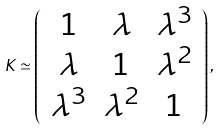<formula> <loc_0><loc_0><loc_500><loc_500>K \simeq \left ( \begin{array} { c c c } 1 & \lambda & \lambda ^ { 3 } \\ \lambda & 1 & \lambda ^ { 2 } \\ \lambda ^ { 3 } & \lambda ^ { 2 } & 1 \end{array} \right ) ,</formula> 